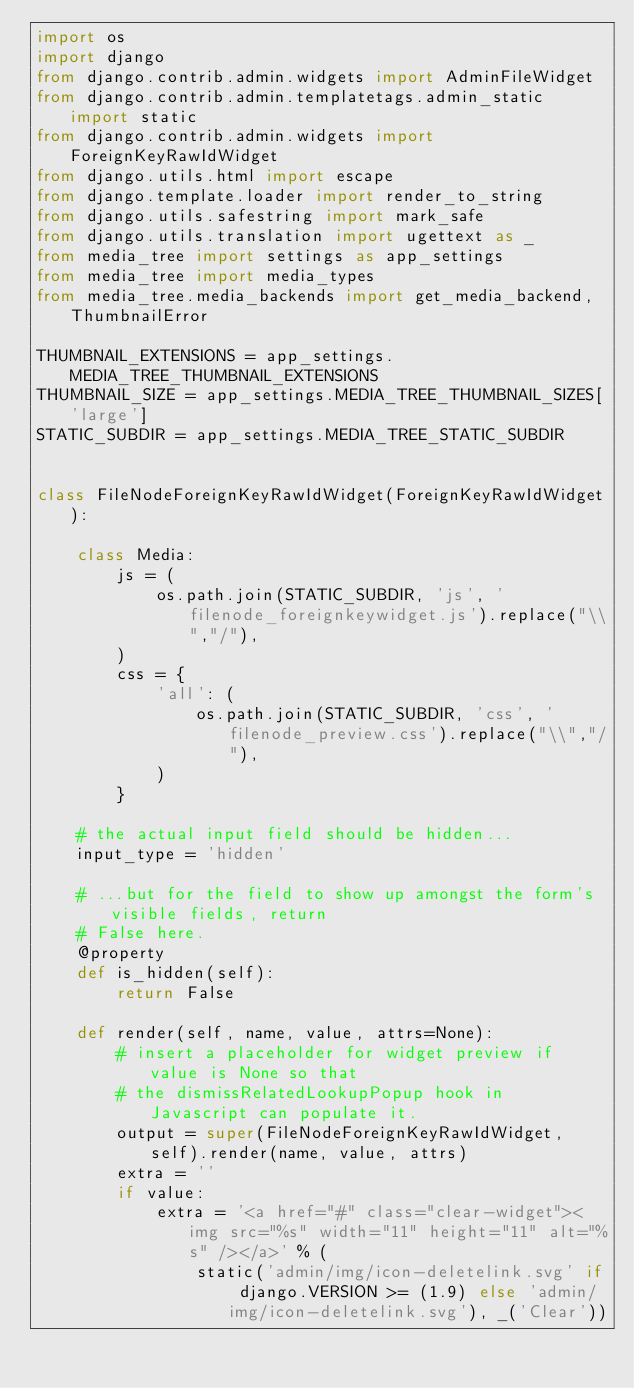Convert code to text. <code><loc_0><loc_0><loc_500><loc_500><_Python_>import os
import django
from django.contrib.admin.widgets import AdminFileWidget
from django.contrib.admin.templatetags.admin_static import static
from django.contrib.admin.widgets import ForeignKeyRawIdWidget
from django.utils.html import escape
from django.template.loader import render_to_string
from django.utils.safestring import mark_safe
from django.utils.translation import ugettext as _
from media_tree import settings as app_settings
from media_tree import media_types
from media_tree.media_backends import get_media_backend, ThumbnailError

THUMBNAIL_EXTENSIONS = app_settings.MEDIA_TREE_THUMBNAIL_EXTENSIONS
THUMBNAIL_SIZE = app_settings.MEDIA_TREE_THUMBNAIL_SIZES['large']
STATIC_SUBDIR = app_settings.MEDIA_TREE_STATIC_SUBDIR


class FileNodeForeignKeyRawIdWidget(ForeignKeyRawIdWidget):

    class Media:
        js = (
            os.path.join(STATIC_SUBDIR, 'js', 'filenode_foreignkeywidget.js').replace("\\","/"),
        )
        css = {
            'all': (
                os.path.join(STATIC_SUBDIR, 'css', 'filenode_preview.css').replace("\\","/"),
            )
        }

    # the actual input field should be hidden...
    input_type = 'hidden'

    # ...but for the field to show up amongst the form's visible fields, return
    # False here.
    @property
    def is_hidden(self):
        return False

    def render(self, name, value, attrs=None):
        # insert a placeholder for widget preview if value is None so that
        # the dismissRelatedLookupPopup hook in Javascript can populate it.
        output = super(FileNodeForeignKeyRawIdWidget, self).render(name, value, attrs)
        extra = ''
        if value:
            extra = '<a href="#" class="clear-widget"><img src="%s" width="11" height="11" alt="%s" /></a>' % (
                static('admin/img/icon-deletelink.svg' if django.VERSION >= (1.9) else 'admin/img/icon-deletelink.svg'), _('Clear'))</code> 